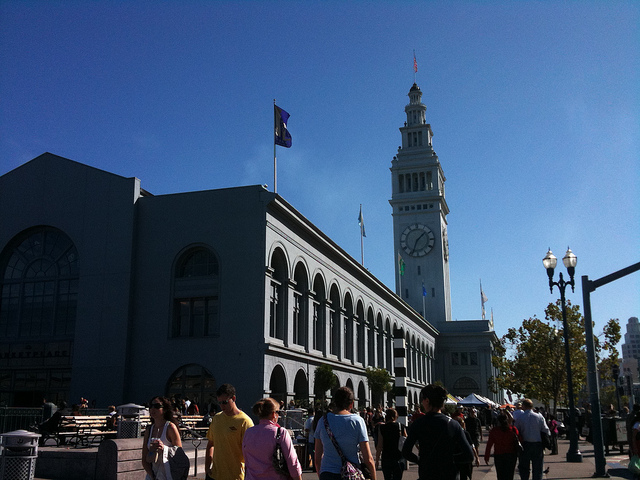<image>What state flag is this? It is unclear what state flag this is as the image is not visible. What color is the street light? It is unclear what color the street light is. The possible colors could be silver, black, white, or green. What state flag is this? I am not sure what state flag it is. It could be Texas, New York, France, or Hartford. What color is the street light? It is unknown what color is the street light. 